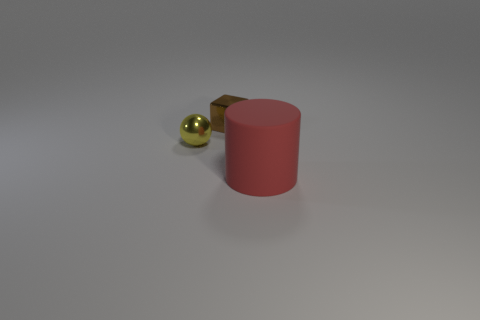What number of small balls are made of the same material as the large thing?
Offer a very short reply. 0. Does the metallic object left of the tiny block have the same size as the object that is to the right of the brown block?
Your response must be concise. No. What color is the tiny thing behind the metallic sphere?
Your answer should be very brief. Brown. How many small metallic spheres have the same color as the small cube?
Offer a very short reply. 0. There is a brown metal cube; does it have the same size as the thing that is left of the tiny brown block?
Ensure brevity in your answer.  Yes. There is a metal object that is right of the small thing in front of the tiny shiny object that is behind the small metallic sphere; what size is it?
Provide a short and direct response. Small. There is a large rubber thing; what number of small brown metal objects are in front of it?
Offer a terse response. 0. There is a small brown object that is to the right of the tiny thing that is in front of the tiny brown metal block; what is its material?
Your response must be concise. Metal. Is there anything else that has the same size as the red matte object?
Your answer should be compact. No. Is the size of the rubber thing the same as the cube?
Offer a very short reply. No. 